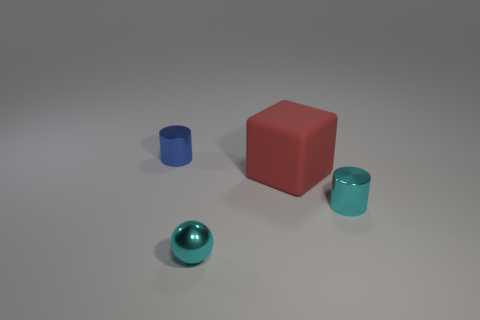Are there any other things that are the same material as the big red block?
Keep it short and to the point. No. Do the big red matte object and the small blue metallic thing have the same shape?
Provide a succinct answer. No. What number of other objects are there of the same color as the big object?
Provide a succinct answer. 0. How many metallic things are in front of the red rubber block and on the left side of the red object?
Provide a succinct answer. 1. Are there any other things that have the same size as the rubber block?
Your response must be concise. No. Is the number of things that are behind the small cyan cylinder greater than the number of metal spheres behind the large red object?
Your answer should be very brief. Yes. There is a tiny cylinder that is on the right side of the cyan shiny sphere; what is its material?
Provide a succinct answer. Metal. There is a tiny blue object; is it the same shape as the shiny thing to the right of the large block?
Offer a very short reply. Yes. How many cyan metallic things are on the left side of the small metal cylinder that is right of the tiny metal thing that is behind the block?
Your response must be concise. 1. There is another object that is the same shape as the blue metallic thing; what color is it?
Your response must be concise. Cyan. 